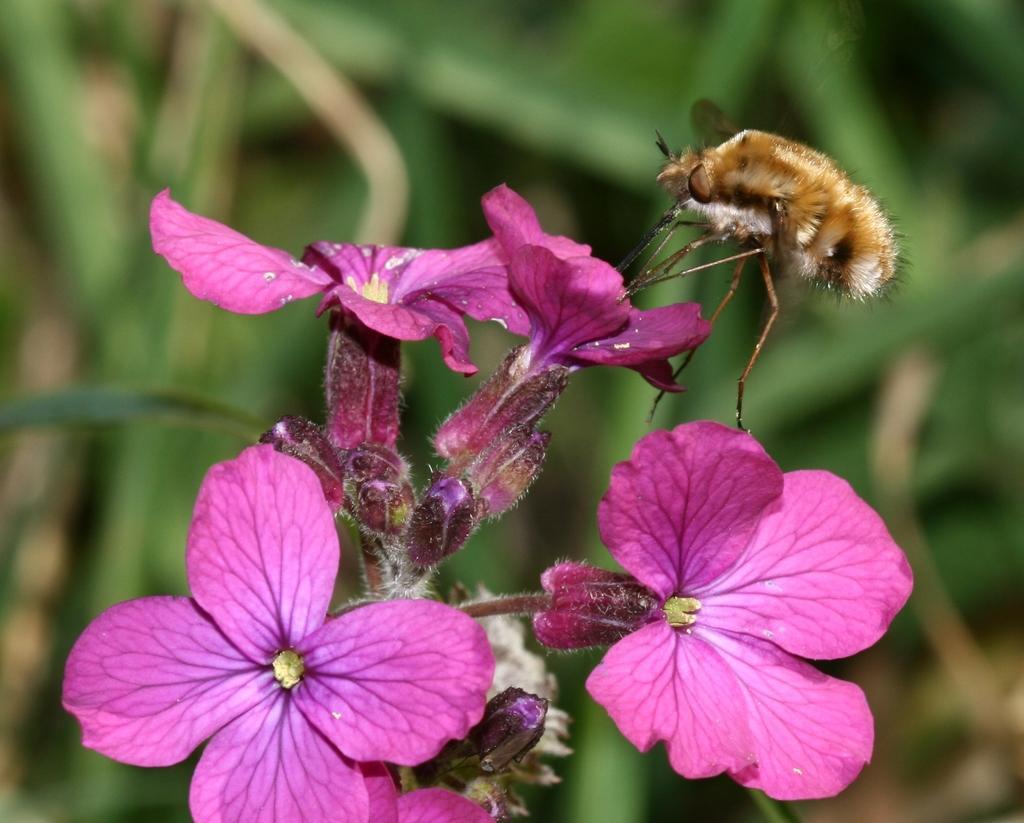Can you describe this image briefly? In this picture we can see an insect, flowers and in the background we can see leaves and it is blurry. 